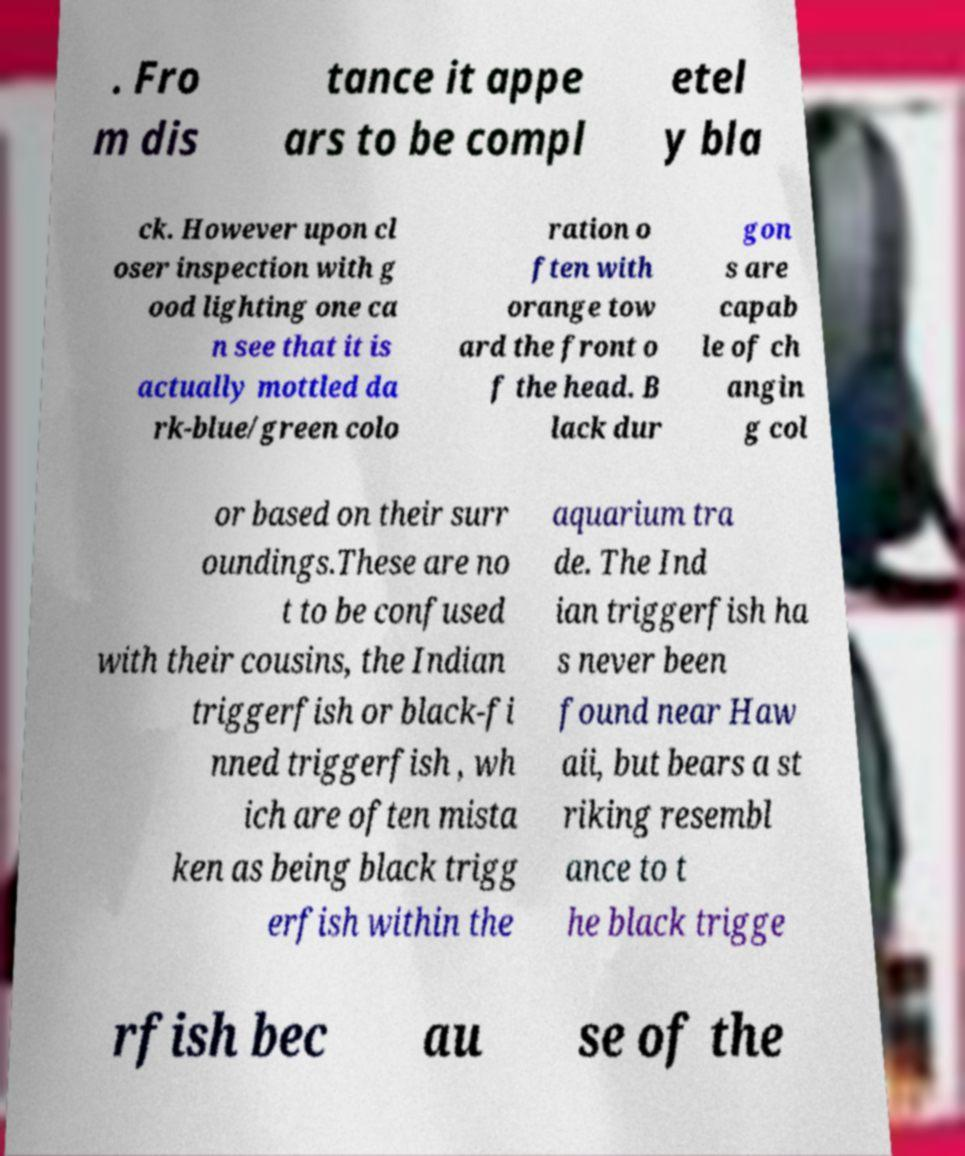What messages or text are displayed in this image? I need them in a readable, typed format. . Fro m dis tance it appe ars to be compl etel y bla ck. However upon cl oser inspection with g ood lighting one ca n see that it is actually mottled da rk-blue/green colo ration o ften with orange tow ard the front o f the head. B lack dur gon s are capab le of ch angin g col or based on their surr oundings.These are no t to be confused with their cousins, the Indian triggerfish or black-fi nned triggerfish , wh ich are often mista ken as being black trigg erfish within the aquarium tra de. The Ind ian triggerfish ha s never been found near Haw aii, but bears a st riking resembl ance to t he black trigge rfish bec au se of the 